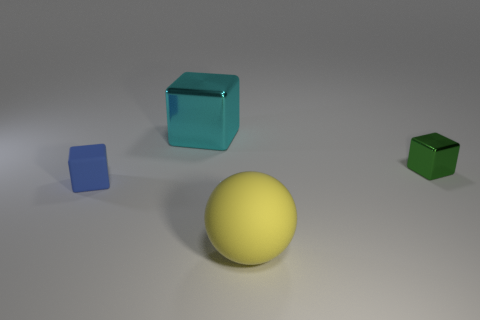There is a tiny cube on the left side of the large yellow rubber ball; what is its color?
Your answer should be compact. Blue. Are there more green metal objects that are on the right side of the small blue cube than brown shiny spheres?
Ensure brevity in your answer.  Yes. There is a large object that is behind the big yellow rubber thing; does it have the same shape as the tiny green shiny object?
Make the answer very short. Yes. What number of blue things are either tiny matte objects or large cylinders?
Provide a short and direct response. 1. Is the number of big cyan things greater than the number of metallic cubes?
Make the answer very short. No. What is the color of the cube that is the same size as the green metallic thing?
Your answer should be very brief. Blue. How many cylinders are small green objects or blue matte things?
Offer a terse response. 0. There is a green thing; is it the same shape as the large object that is in front of the green thing?
Your response must be concise. No. What number of other yellow metal things have the same size as the yellow object?
Ensure brevity in your answer.  0. Does the tiny object right of the large cyan shiny object have the same shape as the rubber object that is behind the yellow matte object?
Your answer should be compact. Yes. 